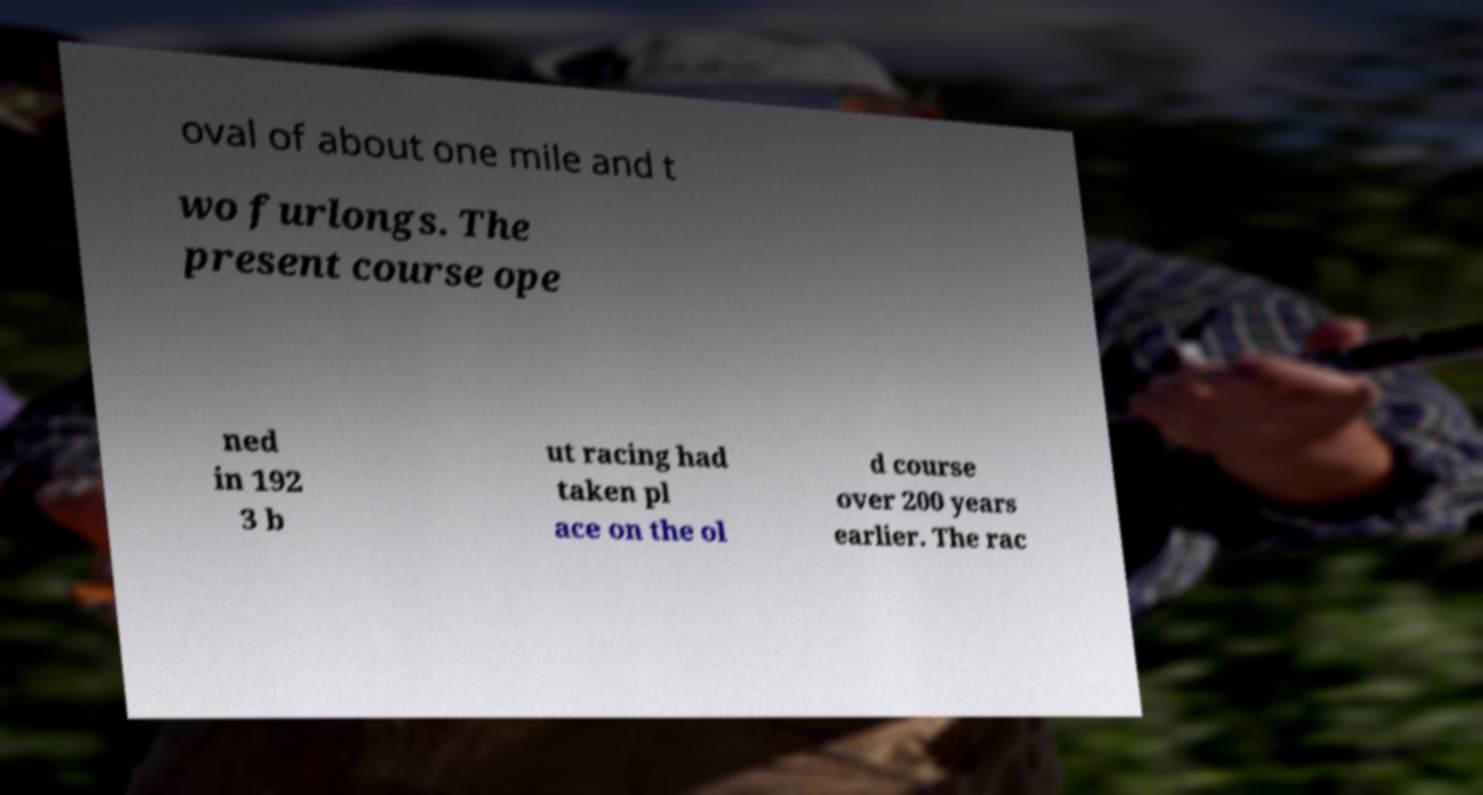Please identify and transcribe the text found in this image. oval of about one mile and t wo furlongs. The present course ope ned in 192 3 b ut racing had taken pl ace on the ol d course over 200 years earlier. The rac 